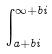Convert formula to latex. <formula><loc_0><loc_0><loc_500><loc_500>\int _ { a + b i } ^ { \infty + b i }</formula> 